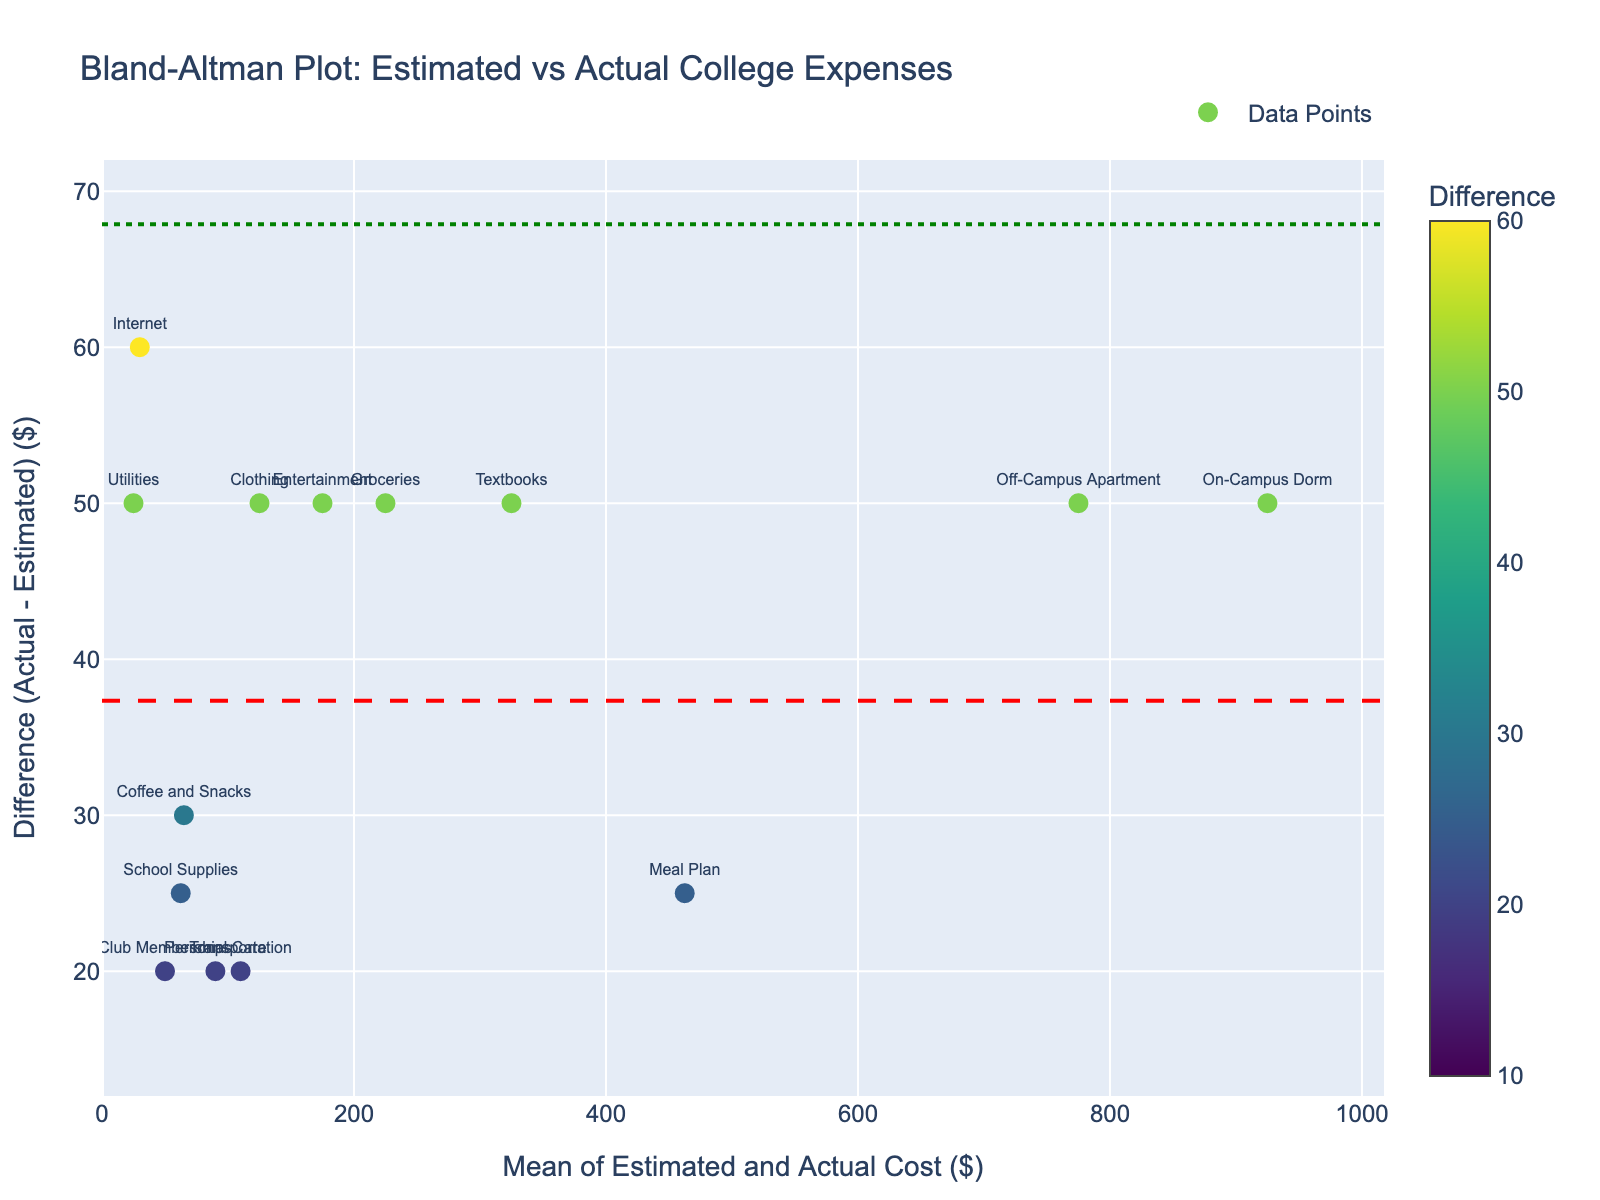What is the title of the plot? The title is clearly indicated at the top of the plot. It reads "Bland-Altman Plot: Estimated vs Actual College Expenses."
Answer: Bland-Altman Plot: Estimated vs Actual College Expenses How many expense categories are represented as data points in the plot? The plot has a scatter plot with each point representing an expense category. There are a total of 15 points, which corresponds to the number of expense categories in the data.
Answer: 15 What are the axes labeled in the plot? The x-axis is labeled "Mean of Estimated and Actual Cost ($)", and the y-axis is labeled "Difference (Actual - Estimated) ($)".
Answer: Mean of Estimated and Actual Cost ($) and Difference (Actual - Estimated) ($) What color represents the data points, and what does this color indicate? The data points are colored using a color scale (Viridis), which indicates the difference between actual and estimated costs. The color bar shows that the color intensity corresponds to the magnitude of the difference.
Answer: Viridis color scale; indicates the magnitude of the difference What are the upper and lower limits of agreement on the plot? The limits of agreement are marked with dot-dashed green lines. The exact numerical values can be read off where these lines intersect the y-axis.
Answer: Look visually on the plot; approximately 88 (upper) and -33 (lower) Which expense category has the highest positive difference between actual and estimated costs? Check the data point with the highest positive y-value (difference) and refer to its label. "Internet" seems to have the highest positive difference.
Answer: Internet Which expense category has the highest negative difference between actual and estimated costs? Identify the data point with the lowest negative y-value (difference) and check its label. "Utilities" appears to have the highest negative difference.
Answer: Utilities What is the mean difference between actual and estimated costs? The mean difference is represented by a red dashed line. The value where this line intersects the y-axis is the mean difference.
Answer: Look visually on the plot; approximately 27.67 Is the majority of the data points located within the limits of agreement? Visual examination of the plot shows that most data points are between the upper and lower limits of agreement, indicating good agreement between estimated and actual costs overall.
Answer: Yes Which expense categories fall outside the limits of agreement? Locate the points outside the green dot-dashed lines (limits of agreement) and check their labels. Those should be the categories like "Internet" and "Utilities."
Answer: Internet, Utilities 